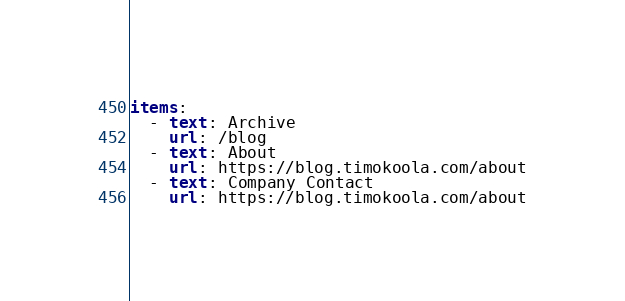Convert code to text. <code><loc_0><loc_0><loc_500><loc_500><_YAML_>items:
  - text: Archive
    url: /blog
  - text: About
    url: https://blog.timokoola.com/about
  - text: Company Contact
    url: https://blog.timokoola.com/about</code> 